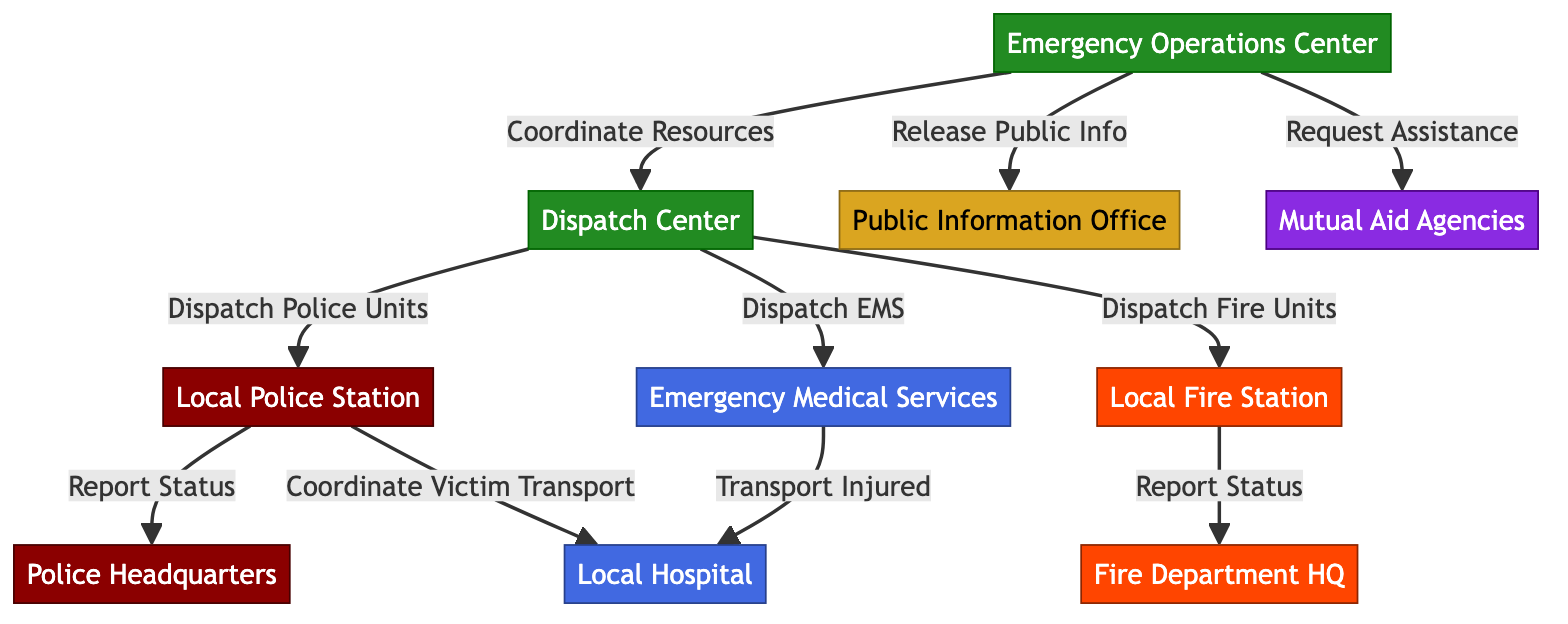What is the total number of nodes in the diagram? Counting the nodes listed in the diagram, there are ten unique entities represented. These include police and fire departments, medical services, coordination centers, and public relations entities.
Answer: 10 Which node is responsible for dispatching police units? The flow in the diagram indicates that the Dispatch Center connects directly to the Local Police Station, which shows that the Dispatch Center is responsible for dispatching police units.
Answer: Dispatch Center How many edges connect to the Local Fire Station? Assessing the connections, the Local Fire Station has two outgoing edges: one connecting it to the Dispatch Center and another reporting status to the Fire Department Headquarters. Thus, there are a total of two edges associated with this node.
Answer: 2 What type of services does the Emergency Medical Services node provide? Reviewing the connections, the Emergency Medical Services node has a direct link to the Local Hospital, indicating that its primary function is to transport injured individuals.
Answer: Transport Injured Who coordinates resources during an emergency? The Emergency Operations Center is the node linked directly to the Dispatch Center for resource coordination, indicating its role in managing resources during emergencies.
Answer: Emergency Operations Center What type of agency is the Public Information Office? By reviewing the classifications given in the diagram, the Public Information Office is categorized under Public Relations, indicating its role in managing communications during emergencies.
Answer: Public Relations Which two nodes have a connection labeled "Report Status"? The Local Police Station and the Fire Department Headquarters are both directly connected by edges labeled "Report Status", indicating they need to report their operational status to their respective headquarters.
Answer: Local Police Station and Fire Department Headquarters How does the Local Police Station coordinate victim transport? The connection from the Local Police Station to the Local Hospital indicates that it coordinates the transport of victims, facilitating their movement to medical services as needed.
Answer: Coordinate Victim Transport What is the relationship between the Emergency Operations Center and Mutual Aid Agencies? The Emergency Operations Center has a direct edge labeled "Request Assistance" leading towards Mutual Aid Agencies, signifying that the center can request help from these external assistance units in emergencies.
Answer: Request Assistance 